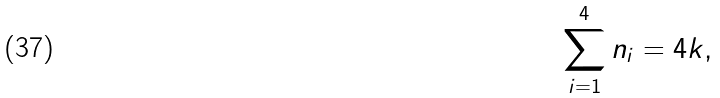<formula> <loc_0><loc_0><loc_500><loc_500>\sum _ { i = 1 } ^ { 4 } n _ { i } = 4 k ,</formula> 